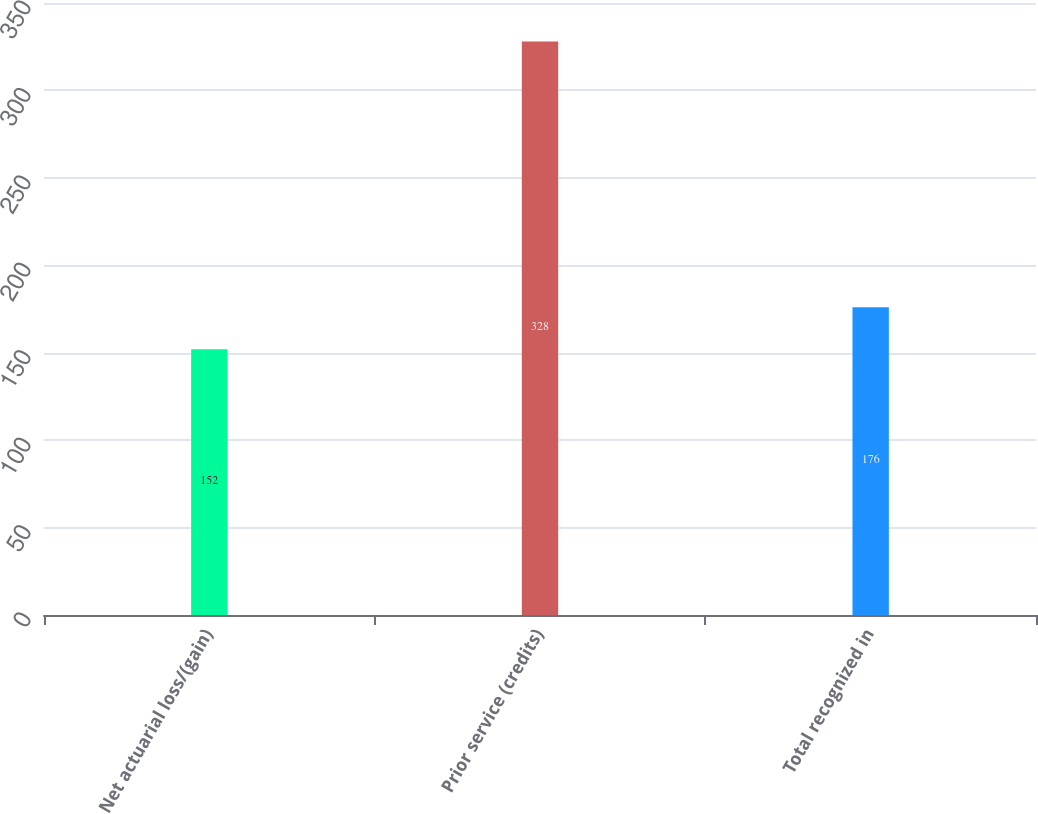Convert chart. <chart><loc_0><loc_0><loc_500><loc_500><bar_chart><fcel>Net actuarial loss/(gain)<fcel>Prior service (credits)<fcel>Total recognized in<nl><fcel>152<fcel>328<fcel>176<nl></chart> 